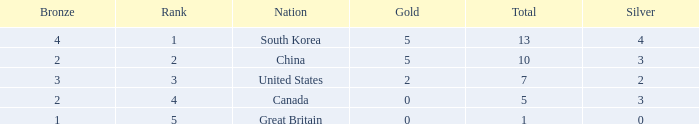What is Nation, when Rank is greater than 2, when Total is greater than 1, and when Bronze is less than 3? Canada. 